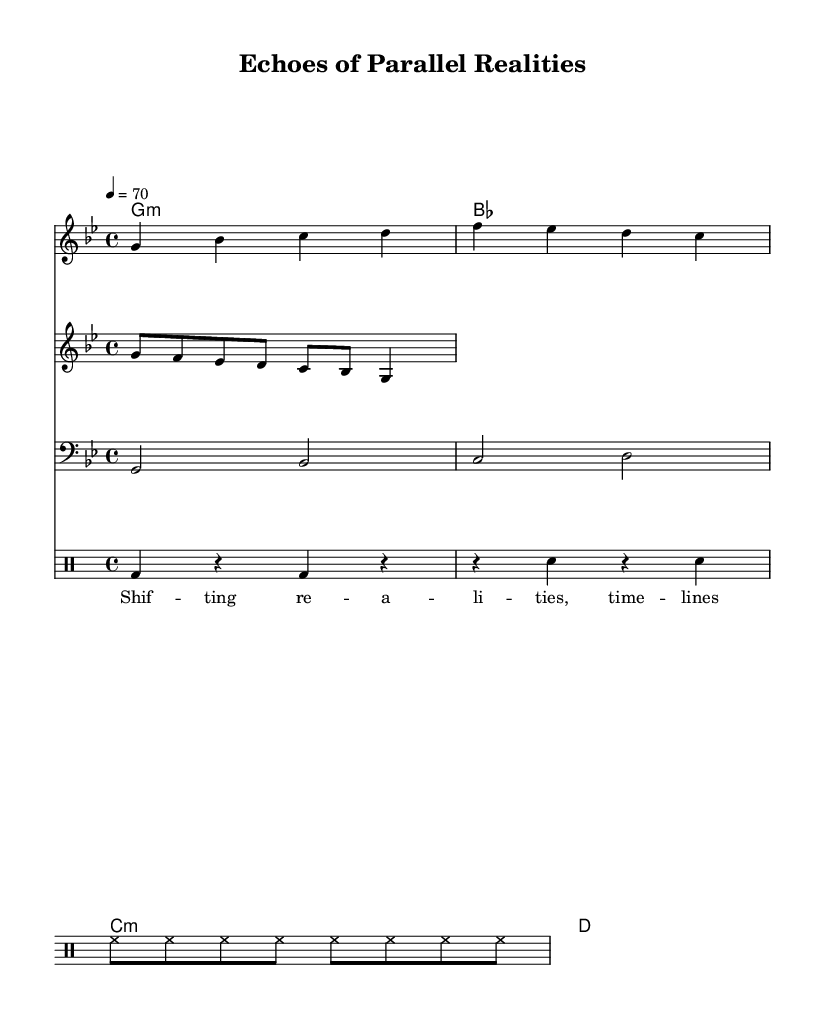What is the key signature of this music? The key signature is G minor, which has two flats: B flat and E flat. This is determined by looking at the key signature in the beginning of the score.
Answer: G minor What is the time signature of the music? The time signature is 4/4, as indicated by the notation at the beginning of the score. This means there are four beats in each measure and the quarter note gets one beat.
Answer: 4/4 What is the tempo marking of the piece? The tempo marking is 70 beats per minute, as shown at the beginning of the score. This indicates the speed at which the music should be played, measured in beats per minute.
Answer: 70 How many lines are in the drum pattern? The drum pattern consists of four lines. A quick glance at the drum staff indicates that four separate rhythmic lines are present, corresponding to various drum components.
Answer: Four What type of rhythm is predominantly used in the keyboard melody? The rhythm in the keyboard melody predominantly uses quarter and eighth notes, which contribute to the typical reggae feel. Observing the notes, quarter notes are shown on the beats while eighth notes add syncopation.
Answer: Quarter and eighth notes What does the lyric "Shif -- ting re -- a -- li -- ties, time -- lines en -- twined" suggest thematically? The lyrics suggest the theme of exploring and intertwining different realities and timelines, which aligns with the concept of parallel universes. The phrasing and structure of the lyrics indicate this narrative being expressed throughout the music.
Answer: The theme of parallel universes 